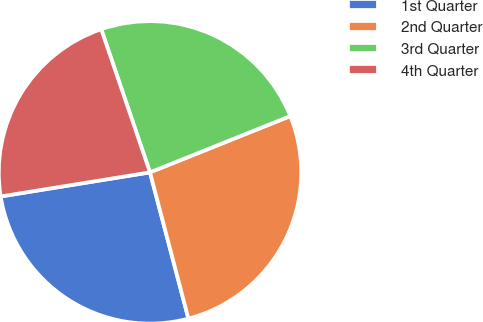Convert chart to OTSL. <chart><loc_0><loc_0><loc_500><loc_500><pie_chart><fcel>1st Quarter<fcel>2nd Quarter<fcel>3rd Quarter<fcel>4th Quarter<nl><fcel>26.54%<fcel>26.98%<fcel>24.15%<fcel>22.32%<nl></chart> 